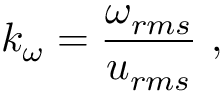Convert formula to latex. <formula><loc_0><loc_0><loc_500><loc_500>k _ { \omega } = \frac { \omega _ { r m s } } { u _ { r m s } } ,</formula> 